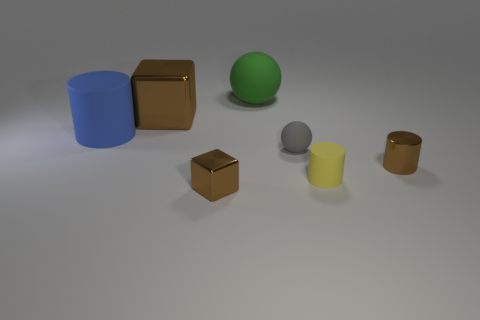Is the tiny metallic cube the same color as the small matte cylinder?
Your answer should be compact. No. What material is the other cube that is the same color as the big block?
Give a very brief answer. Metal. There is a large green thing that is made of the same material as the large blue object; what shape is it?
Give a very brief answer. Sphere. Is there anything else that is the same color as the tiny sphere?
Ensure brevity in your answer.  No. What number of tiny brown cylinders are there?
Offer a very short reply. 1. The large object that is both in front of the large green matte object and to the right of the big blue matte thing has what shape?
Offer a terse response. Cube. What is the shape of the matte thing that is in front of the tiny metallic thing that is to the right of the brown block in front of the brown shiny cylinder?
Your answer should be compact. Cylinder. What is the material of the object that is to the right of the tiny brown metal block and behind the tiny gray rubber object?
Ensure brevity in your answer.  Rubber. What number of gray objects have the same size as the yellow thing?
Your answer should be very brief. 1. What number of rubber objects are either small yellow things or large cyan balls?
Provide a succinct answer. 1. 